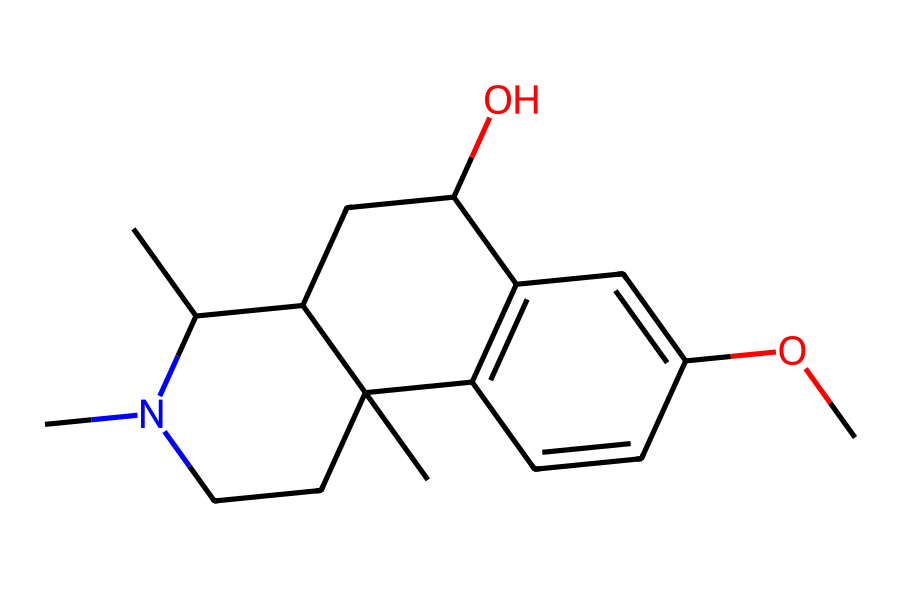What is the molecular formula of dextromethorphan? To find the molecular formula, we count the carbon (C), hydrogen (H), nitrogen (N), and oxygen (O) atoms from the structure. The SMILES indicates there are 18 carbons, 25 hydrogens, 1 nitrogen, and 1 oxygen. Therefore, the molecular formula is C18H25N1O1.
Answer: C18H25NO How many stereocenters does dextromethorphan contain? A stereocenter is typically defined by a carbon atom bonded to four different substituents. By analyzing the structure, we find there are two carbon atoms meeting these criteria. Thus, there are two stereocenters in dextromethorphan.
Answer: 2 What type of molecular symmetry does dextromethorphan exhibit? The presence of two stereocenters in the structure indicates that it has a chiral center and lacks a plane of symmetry. Therefore, dextromethorphan exhibits a chiral symmetry.
Answer: chiral What functional groups are present in dextromethorphan? Looking at the structure, we can note the presence of an ether group (from the -O- linkage) and an alcohol group (from the -OH group). These groups contribute to the chemical's properties.
Answer: ether and alcohol What is the significance of dextromethorphan being a chiral compound? The chirality of dextromethorphan means it can exist in two enantiomeric forms, which can have different biological activities. Specifically, one enantiomer may be effective as a cough suppressant, while the other might not provide the same effect.
Answer: different biological activities How many double bonds are in dextromethorphan? By inspecting the structure closely, we note there are two double bonds present in the ring systems of the molecule.
Answer: 2 What is the primary use of dextromethorphan? Dextromethorphan is primarily used as a cough suppressant in over-the-counter medications. Its effectiveness in treating cough makes it a common ingredient in cold remedies.
Answer: cough suppressant 